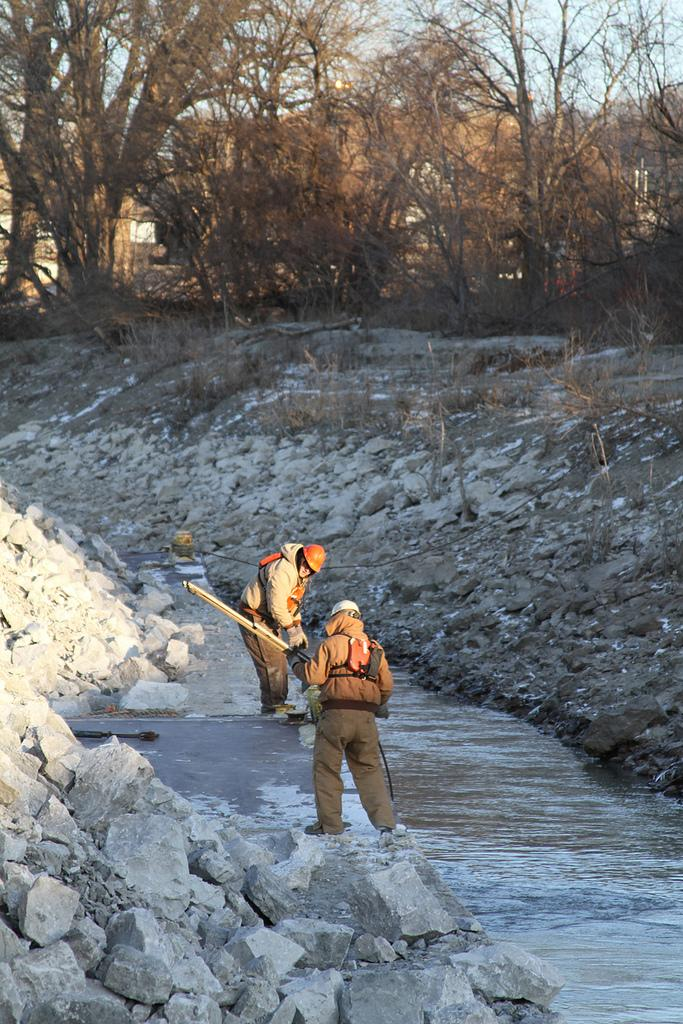How many people are in the image? There are two people standing in the image. What are the people holding? The people are holding something, but the facts do not specify what it is. What type of natural elements can be seen in the image? There are stones, water, and dry trees visible in the image. What is the color of the sky in the image? The sky is blue in color. What type of fruit is being carried by the horse in the image? There is no horse present in the image, and therefore no fruit being carried by a horse. What type of lumber is visible in the image? There is no lumber visible in the image. 